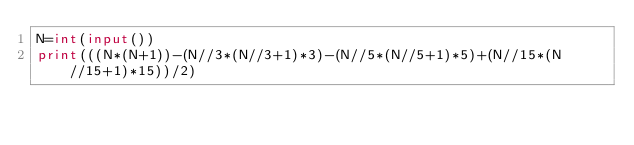Convert code to text. <code><loc_0><loc_0><loc_500><loc_500><_Python_>N=int(input())
print(((N*(N+1))-(N//3*(N//3+1)*3)-(N//5*(N//5+1)*5)+(N//15*(N//15+1)*15))/2)</code> 